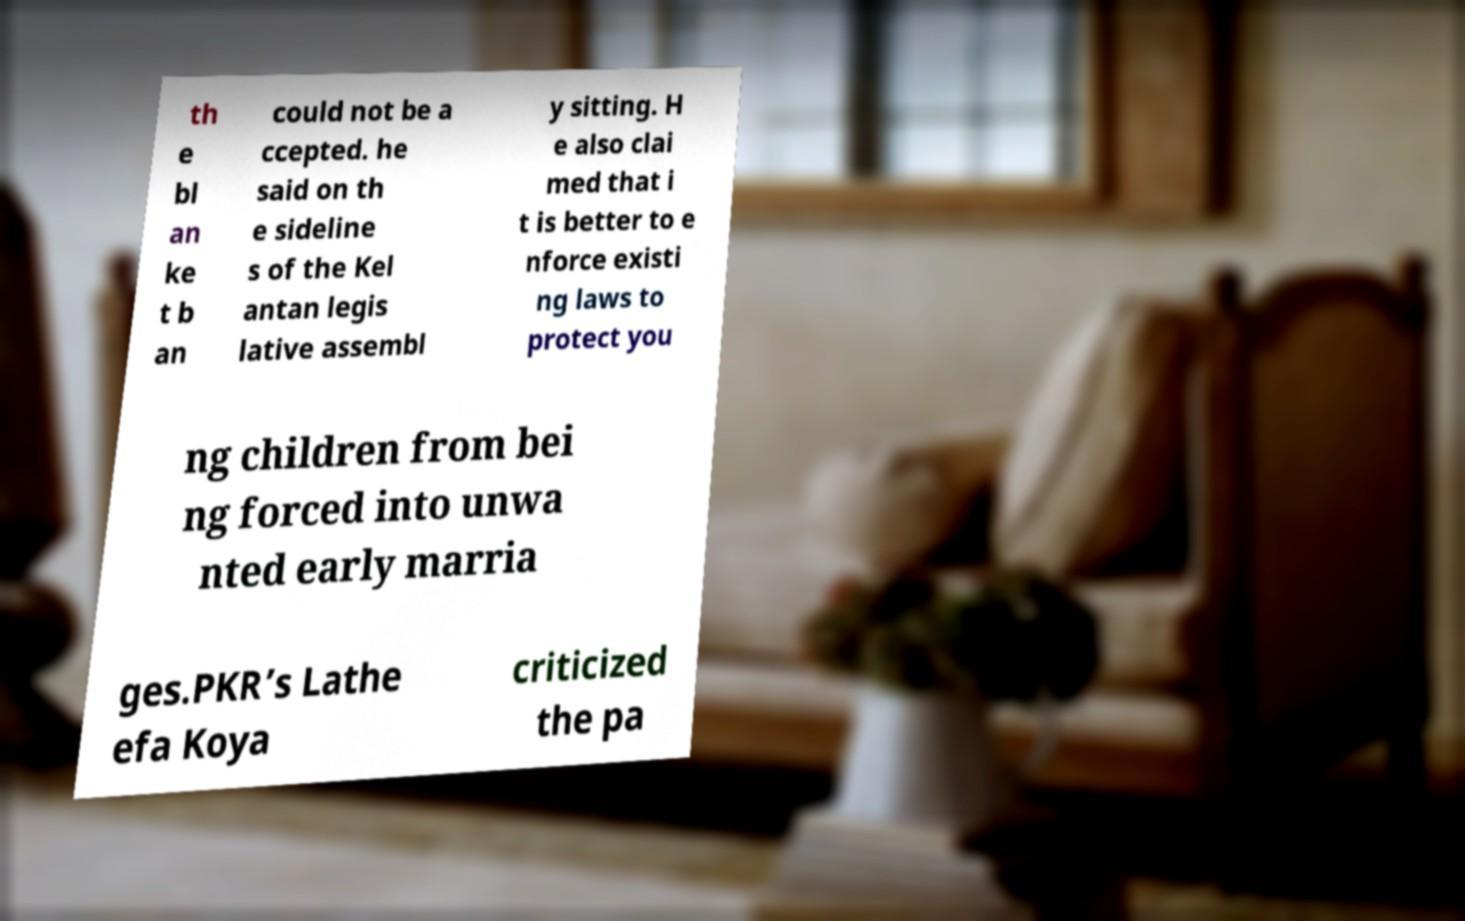I need the written content from this picture converted into text. Can you do that? th e bl an ke t b an could not be a ccepted. he said on th e sideline s of the Kel antan legis lative assembl y sitting. H e also clai med that i t is better to e nforce existi ng laws to protect you ng children from bei ng forced into unwa nted early marria ges.PKR’s Lathe efa Koya criticized the pa 